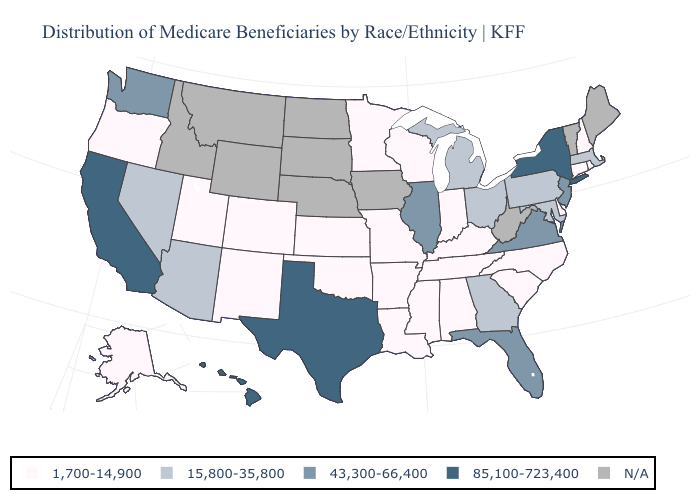What is the lowest value in the West?
Write a very short answer. 1,700-14,900. Among the states that border North Carolina , which have the lowest value?
Give a very brief answer. South Carolina, Tennessee. What is the highest value in the South ?
Quick response, please. 85,100-723,400. What is the value of Indiana?
Be succinct. 1,700-14,900. Which states have the highest value in the USA?
Quick response, please. California, Hawaii, New York, Texas. Which states have the lowest value in the USA?
Concise answer only. Alabama, Alaska, Arkansas, Colorado, Connecticut, Delaware, Indiana, Kansas, Kentucky, Louisiana, Minnesota, Mississippi, Missouri, New Hampshire, New Mexico, North Carolina, Oklahoma, Oregon, Rhode Island, South Carolina, Tennessee, Utah, Wisconsin. Which states have the lowest value in the USA?
Answer briefly. Alabama, Alaska, Arkansas, Colorado, Connecticut, Delaware, Indiana, Kansas, Kentucky, Louisiana, Minnesota, Mississippi, Missouri, New Hampshire, New Mexico, North Carolina, Oklahoma, Oregon, Rhode Island, South Carolina, Tennessee, Utah, Wisconsin. What is the value of South Dakota?
Keep it brief. N/A. What is the highest value in the West ?
Keep it brief. 85,100-723,400. Is the legend a continuous bar?
Keep it brief. No. What is the highest value in the West ?
Short answer required. 85,100-723,400. Name the states that have a value in the range 1,700-14,900?
Answer briefly. Alabama, Alaska, Arkansas, Colorado, Connecticut, Delaware, Indiana, Kansas, Kentucky, Louisiana, Minnesota, Mississippi, Missouri, New Hampshire, New Mexico, North Carolina, Oklahoma, Oregon, Rhode Island, South Carolina, Tennessee, Utah, Wisconsin. Does Connecticut have the lowest value in the Northeast?
Concise answer only. Yes. Does the map have missing data?
Give a very brief answer. Yes. 